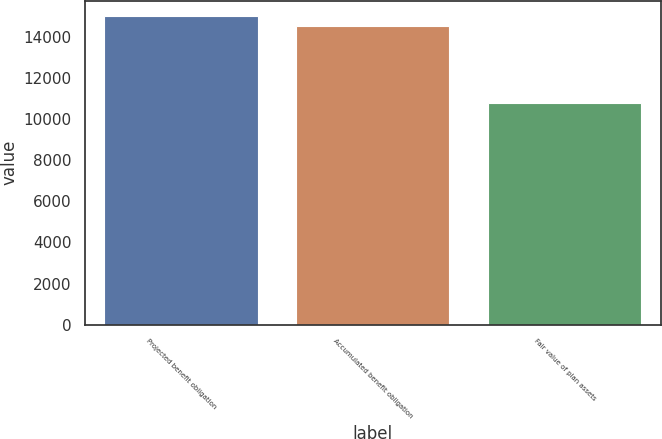Convert chart to OTSL. <chart><loc_0><loc_0><loc_500><loc_500><bar_chart><fcel>Projected benefit obligation<fcel>Accumulated benefit obligation<fcel>Fair value of plan assets<nl><fcel>15019<fcel>14553<fcel>10777<nl></chart> 